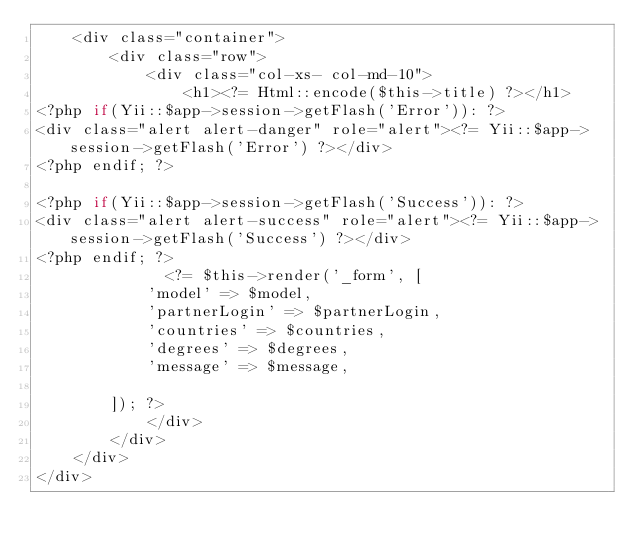<code> <loc_0><loc_0><loc_500><loc_500><_PHP_>	<div class="container">
		<div class="row">
			<div class="col-xs- col-md-10">  
			    <h1><?= Html::encode($this->title) ?></h1>
<?php if(Yii::$app->session->getFlash('Error')): ?>
<div class="alert alert-danger" role="alert"><?= Yii::$app->session->getFlash('Error') ?></div>
<?php endif; ?>

<?php if(Yii::$app->session->getFlash('Success')): ?>
<div class="alert alert-success" role="alert"><?= Yii::$app->session->getFlash('Success') ?></div>
<?php endif; ?>
			  <?= $this->render('_form', [
            'model' => $model, 
			'partnerLogin' => $partnerLogin,
            'countries' => $countries,
			'degrees' => $degrees,
            'message' => $message,
			
        ]); ?>
			</div>
		</div>
	</div>
</div>
</code> 